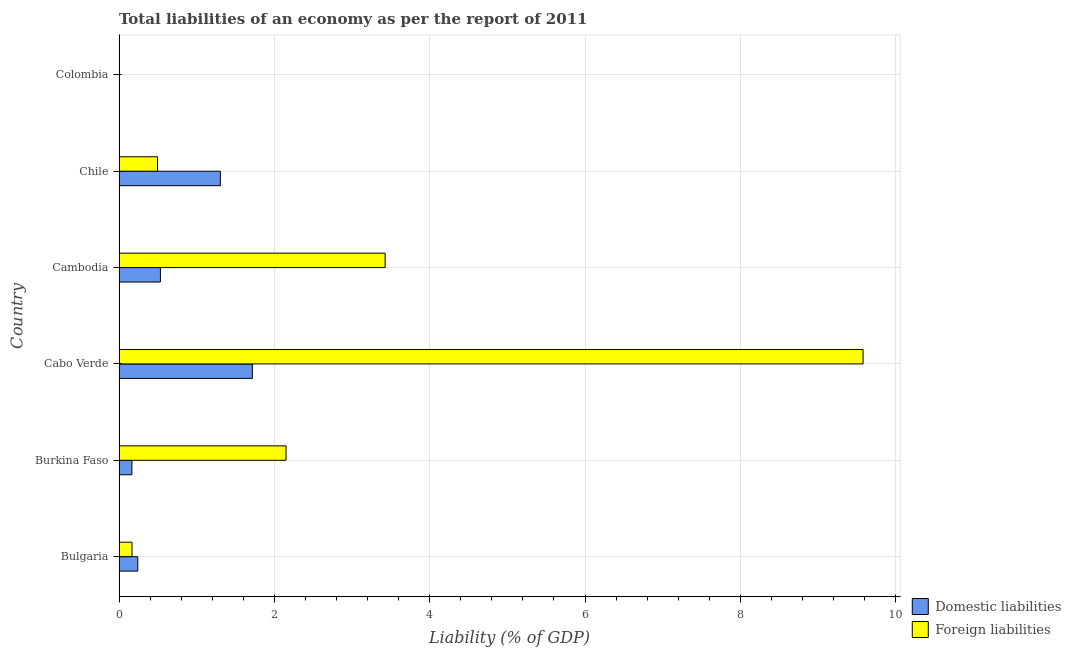Are the number of bars per tick equal to the number of legend labels?
Your answer should be very brief. No. What is the label of the 1st group of bars from the top?
Give a very brief answer. Colombia. In how many cases, is the number of bars for a given country not equal to the number of legend labels?
Ensure brevity in your answer.  1. What is the incurrence of foreign liabilities in Cambodia?
Offer a terse response. 3.43. Across all countries, what is the maximum incurrence of foreign liabilities?
Ensure brevity in your answer.  9.58. Across all countries, what is the minimum incurrence of domestic liabilities?
Ensure brevity in your answer.  0. In which country was the incurrence of foreign liabilities maximum?
Give a very brief answer. Cabo Verde. What is the total incurrence of domestic liabilities in the graph?
Keep it short and to the point. 3.96. What is the difference between the incurrence of foreign liabilities in Bulgaria and that in Burkina Faso?
Ensure brevity in your answer.  -1.98. What is the difference between the incurrence of foreign liabilities in Chile and the incurrence of domestic liabilities in Cabo Verde?
Make the answer very short. -1.22. What is the average incurrence of domestic liabilities per country?
Provide a succinct answer. 0.66. What is the difference between the incurrence of domestic liabilities and incurrence of foreign liabilities in Burkina Faso?
Provide a succinct answer. -1.99. In how many countries, is the incurrence of foreign liabilities greater than 9.2 %?
Give a very brief answer. 1. What is the ratio of the incurrence of domestic liabilities in Bulgaria to that in Cambodia?
Your response must be concise. 0.45. Is the incurrence of foreign liabilities in Burkina Faso less than that in Cabo Verde?
Ensure brevity in your answer.  Yes. Is the difference between the incurrence of domestic liabilities in Cabo Verde and Chile greater than the difference between the incurrence of foreign liabilities in Cabo Verde and Chile?
Make the answer very short. No. What is the difference between the highest and the second highest incurrence of domestic liabilities?
Make the answer very short. 0.41. What is the difference between the highest and the lowest incurrence of domestic liabilities?
Your answer should be very brief. 1.72. How many bars are there?
Offer a very short reply. 10. How many countries are there in the graph?
Ensure brevity in your answer.  6. Does the graph contain grids?
Your response must be concise. Yes. Where does the legend appear in the graph?
Your response must be concise. Bottom right. What is the title of the graph?
Give a very brief answer. Total liabilities of an economy as per the report of 2011. Does "Diesel" appear as one of the legend labels in the graph?
Provide a short and direct response. No. What is the label or title of the X-axis?
Your answer should be very brief. Liability (% of GDP). What is the label or title of the Y-axis?
Offer a very short reply. Country. What is the Liability (% of GDP) of Domestic liabilities in Bulgaria?
Make the answer very short. 0.24. What is the Liability (% of GDP) of Foreign liabilities in Bulgaria?
Your answer should be very brief. 0.17. What is the Liability (% of GDP) in Domestic liabilities in Burkina Faso?
Offer a very short reply. 0.17. What is the Liability (% of GDP) in Foreign liabilities in Burkina Faso?
Your answer should be very brief. 2.15. What is the Liability (% of GDP) in Domestic liabilities in Cabo Verde?
Provide a short and direct response. 1.72. What is the Liability (% of GDP) of Foreign liabilities in Cabo Verde?
Your answer should be very brief. 9.58. What is the Liability (% of GDP) of Domestic liabilities in Cambodia?
Provide a short and direct response. 0.53. What is the Liability (% of GDP) in Foreign liabilities in Cambodia?
Make the answer very short. 3.43. What is the Liability (% of GDP) in Domestic liabilities in Chile?
Keep it short and to the point. 1.3. What is the Liability (% of GDP) of Foreign liabilities in Chile?
Your answer should be compact. 0.5. What is the Liability (% of GDP) of Domestic liabilities in Colombia?
Your answer should be compact. 0. Across all countries, what is the maximum Liability (% of GDP) of Domestic liabilities?
Provide a succinct answer. 1.72. Across all countries, what is the maximum Liability (% of GDP) in Foreign liabilities?
Keep it short and to the point. 9.58. Across all countries, what is the minimum Liability (% of GDP) in Domestic liabilities?
Offer a terse response. 0. Across all countries, what is the minimum Liability (% of GDP) in Foreign liabilities?
Give a very brief answer. 0. What is the total Liability (% of GDP) of Domestic liabilities in the graph?
Provide a succinct answer. 3.96. What is the total Liability (% of GDP) of Foreign liabilities in the graph?
Offer a terse response. 15.82. What is the difference between the Liability (% of GDP) of Domestic liabilities in Bulgaria and that in Burkina Faso?
Offer a very short reply. 0.08. What is the difference between the Liability (% of GDP) in Foreign liabilities in Bulgaria and that in Burkina Faso?
Give a very brief answer. -1.98. What is the difference between the Liability (% of GDP) of Domestic liabilities in Bulgaria and that in Cabo Verde?
Provide a short and direct response. -1.48. What is the difference between the Liability (% of GDP) of Foreign liabilities in Bulgaria and that in Cabo Verde?
Your answer should be very brief. -9.41. What is the difference between the Liability (% of GDP) in Domestic liabilities in Bulgaria and that in Cambodia?
Your answer should be very brief. -0.29. What is the difference between the Liability (% of GDP) of Foreign liabilities in Bulgaria and that in Cambodia?
Offer a terse response. -3.26. What is the difference between the Liability (% of GDP) of Domestic liabilities in Bulgaria and that in Chile?
Your response must be concise. -1.06. What is the difference between the Liability (% of GDP) in Foreign liabilities in Bulgaria and that in Chile?
Give a very brief answer. -0.33. What is the difference between the Liability (% of GDP) in Domestic liabilities in Burkina Faso and that in Cabo Verde?
Give a very brief answer. -1.55. What is the difference between the Liability (% of GDP) in Foreign liabilities in Burkina Faso and that in Cabo Verde?
Offer a very short reply. -7.43. What is the difference between the Liability (% of GDP) of Domestic liabilities in Burkina Faso and that in Cambodia?
Provide a succinct answer. -0.37. What is the difference between the Liability (% of GDP) of Foreign liabilities in Burkina Faso and that in Cambodia?
Ensure brevity in your answer.  -1.28. What is the difference between the Liability (% of GDP) in Domestic liabilities in Burkina Faso and that in Chile?
Provide a succinct answer. -1.14. What is the difference between the Liability (% of GDP) of Foreign liabilities in Burkina Faso and that in Chile?
Your response must be concise. 1.65. What is the difference between the Liability (% of GDP) of Domestic liabilities in Cabo Verde and that in Cambodia?
Make the answer very short. 1.18. What is the difference between the Liability (% of GDP) of Foreign liabilities in Cabo Verde and that in Cambodia?
Ensure brevity in your answer.  6.15. What is the difference between the Liability (% of GDP) of Domestic liabilities in Cabo Verde and that in Chile?
Offer a terse response. 0.41. What is the difference between the Liability (% of GDP) of Foreign liabilities in Cabo Verde and that in Chile?
Ensure brevity in your answer.  9.08. What is the difference between the Liability (% of GDP) of Domestic liabilities in Cambodia and that in Chile?
Offer a very short reply. -0.77. What is the difference between the Liability (% of GDP) of Foreign liabilities in Cambodia and that in Chile?
Make the answer very short. 2.93. What is the difference between the Liability (% of GDP) in Domestic liabilities in Bulgaria and the Liability (% of GDP) in Foreign liabilities in Burkina Faso?
Your answer should be very brief. -1.91. What is the difference between the Liability (% of GDP) in Domestic liabilities in Bulgaria and the Liability (% of GDP) in Foreign liabilities in Cabo Verde?
Your answer should be very brief. -9.34. What is the difference between the Liability (% of GDP) of Domestic liabilities in Bulgaria and the Liability (% of GDP) of Foreign liabilities in Cambodia?
Give a very brief answer. -3.18. What is the difference between the Liability (% of GDP) of Domestic liabilities in Bulgaria and the Liability (% of GDP) of Foreign liabilities in Chile?
Your answer should be compact. -0.25. What is the difference between the Liability (% of GDP) of Domestic liabilities in Burkina Faso and the Liability (% of GDP) of Foreign liabilities in Cabo Verde?
Give a very brief answer. -9.41. What is the difference between the Liability (% of GDP) in Domestic liabilities in Burkina Faso and the Liability (% of GDP) in Foreign liabilities in Cambodia?
Provide a succinct answer. -3.26. What is the difference between the Liability (% of GDP) of Domestic liabilities in Burkina Faso and the Liability (% of GDP) of Foreign liabilities in Chile?
Give a very brief answer. -0.33. What is the difference between the Liability (% of GDP) of Domestic liabilities in Cabo Verde and the Liability (% of GDP) of Foreign liabilities in Cambodia?
Offer a terse response. -1.71. What is the difference between the Liability (% of GDP) in Domestic liabilities in Cabo Verde and the Liability (% of GDP) in Foreign liabilities in Chile?
Your answer should be compact. 1.22. What is the difference between the Liability (% of GDP) of Domestic liabilities in Cambodia and the Liability (% of GDP) of Foreign liabilities in Chile?
Your response must be concise. 0.04. What is the average Liability (% of GDP) in Domestic liabilities per country?
Keep it short and to the point. 0.66. What is the average Liability (% of GDP) of Foreign liabilities per country?
Make the answer very short. 2.64. What is the difference between the Liability (% of GDP) of Domestic liabilities and Liability (% of GDP) of Foreign liabilities in Bulgaria?
Give a very brief answer. 0.07. What is the difference between the Liability (% of GDP) in Domestic liabilities and Liability (% of GDP) in Foreign liabilities in Burkina Faso?
Offer a very short reply. -1.98. What is the difference between the Liability (% of GDP) in Domestic liabilities and Liability (% of GDP) in Foreign liabilities in Cabo Verde?
Keep it short and to the point. -7.86. What is the difference between the Liability (% of GDP) in Domestic liabilities and Liability (% of GDP) in Foreign liabilities in Cambodia?
Your answer should be very brief. -2.89. What is the difference between the Liability (% of GDP) of Domestic liabilities and Liability (% of GDP) of Foreign liabilities in Chile?
Provide a short and direct response. 0.81. What is the ratio of the Liability (% of GDP) in Domestic liabilities in Bulgaria to that in Burkina Faso?
Make the answer very short. 1.46. What is the ratio of the Liability (% of GDP) of Foreign liabilities in Bulgaria to that in Burkina Faso?
Your answer should be compact. 0.08. What is the ratio of the Liability (% of GDP) in Domestic liabilities in Bulgaria to that in Cabo Verde?
Provide a succinct answer. 0.14. What is the ratio of the Liability (% of GDP) of Foreign liabilities in Bulgaria to that in Cabo Verde?
Offer a terse response. 0.02. What is the ratio of the Liability (% of GDP) in Domestic liabilities in Bulgaria to that in Cambodia?
Make the answer very short. 0.45. What is the ratio of the Liability (% of GDP) of Foreign liabilities in Bulgaria to that in Cambodia?
Keep it short and to the point. 0.05. What is the ratio of the Liability (% of GDP) in Domestic liabilities in Bulgaria to that in Chile?
Your answer should be compact. 0.18. What is the ratio of the Liability (% of GDP) in Foreign liabilities in Bulgaria to that in Chile?
Offer a very short reply. 0.34. What is the ratio of the Liability (% of GDP) in Domestic liabilities in Burkina Faso to that in Cabo Verde?
Ensure brevity in your answer.  0.1. What is the ratio of the Liability (% of GDP) of Foreign liabilities in Burkina Faso to that in Cabo Verde?
Provide a succinct answer. 0.22. What is the ratio of the Liability (% of GDP) in Domestic liabilities in Burkina Faso to that in Cambodia?
Keep it short and to the point. 0.31. What is the ratio of the Liability (% of GDP) in Foreign liabilities in Burkina Faso to that in Cambodia?
Give a very brief answer. 0.63. What is the ratio of the Liability (% of GDP) of Domestic liabilities in Burkina Faso to that in Chile?
Provide a short and direct response. 0.13. What is the ratio of the Liability (% of GDP) in Foreign liabilities in Burkina Faso to that in Chile?
Provide a succinct answer. 4.34. What is the ratio of the Liability (% of GDP) of Domestic liabilities in Cabo Verde to that in Cambodia?
Offer a terse response. 3.22. What is the ratio of the Liability (% of GDP) in Foreign liabilities in Cabo Verde to that in Cambodia?
Make the answer very short. 2.8. What is the ratio of the Liability (% of GDP) of Domestic liabilities in Cabo Verde to that in Chile?
Provide a short and direct response. 1.32. What is the ratio of the Liability (% of GDP) of Foreign liabilities in Cabo Verde to that in Chile?
Keep it short and to the point. 19.33. What is the ratio of the Liability (% of GDP) in Domestic liabilities in Cambodia to that in Chile?
Offer a very short reply. 0.41. What is the ratio of the Liability (% of GDP) of Foreign liabilities in Cambodia to that in Chile?
Provide a succinct answer. 6.91. What is the difference between the highest and the second highest Liability (% of GDP) of Domestic liabilities?
Your response must be concise. 0.41. What is the difference between the highest and the second highest Liability (% of GDP) in Foreign liabilities?
Your response must be concise. 6.15. What is the difference between the highest and the lowest Liability (% of GDP) of Domestic liabilities?
Your answer should be very brief. 1.72. What is the difference between the highest and the lowest Liability (% of GDP) of Foreign liabilities?
Make the answer very short. 9.58. 